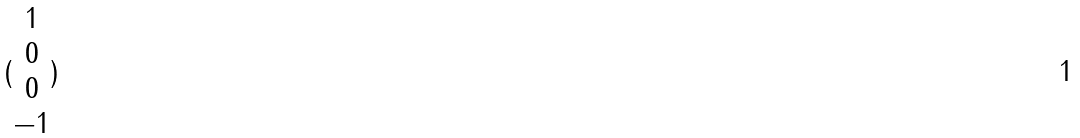<formula> <loc_0><loc_0><loc_500><loc_500>( \begin{matrix} 1 \\ 0 \\ 0 \\ - 1 \end{matrix} )</formula> 